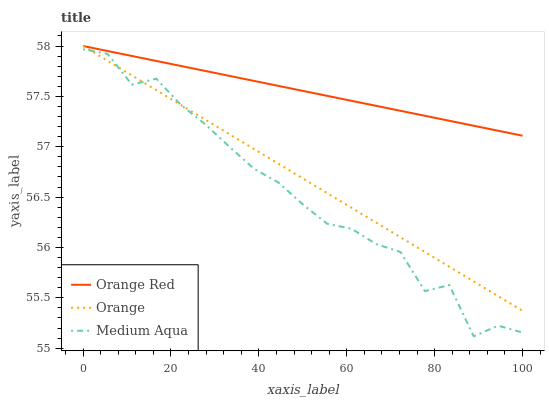Does Orange Red have the minimum area under the curve?
Answer yes or no. No. Does Medium Aqua have the maximum area under the curve?
Answer yes or no. No. Is Medium Aqua the smoothest?
Answer yes or no. No. Is Orange Red the roughest?
Answer yes or no. No. Does Orange Red have the lowest value?
Answer yes or no. No. Does Medium Aqua have the highest value?
Answer yes or no. No. Is Medium Aqua less than Orange Red?
Answer yes or no. Yes. Is Orange Red greater than Medium Aqua?
Answer yes or no. Yes. Does Medium Aqua intersect Orange Red?
Answer yes or no. No. 